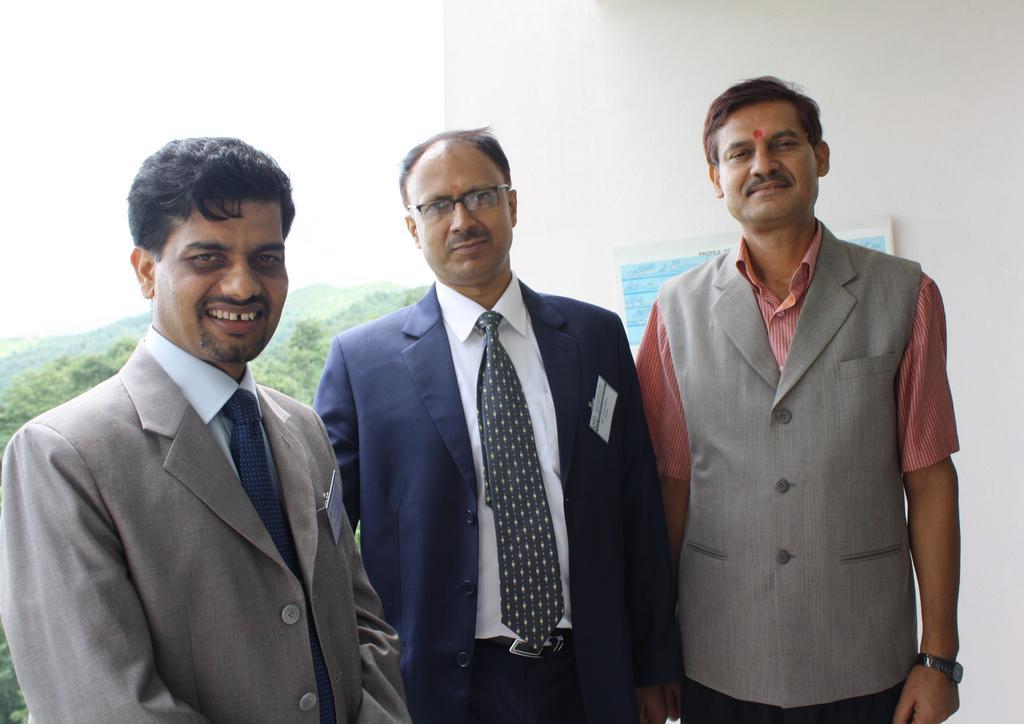Can you describe this image briefly? In this image, we can see three men are standing, seeing and smiling. Background there is a wall with poster, trees and sky. 